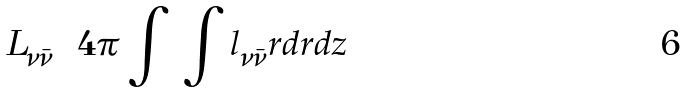Convert formula to latex. <formula><loc_0><loc_0><loc_500><loc_500>L _ { \nu \bar { \nu } } = 4 \pi \int \, \int { l _ { \nu \bar { \nu } } r d r d z }</formula> 